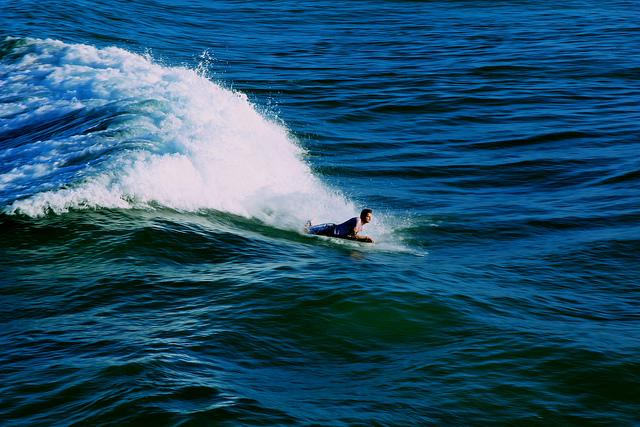What color is the water?
Give a very brief answer. Blue. What is the kid riding one?
Concise answer only. Surfboard. Is this underwater?
Write a very short answer. No. Will the wave overtake the man?
Be succinct. Yes. What is the man during on the ocean wave?
Concise answer only. Surfing. 